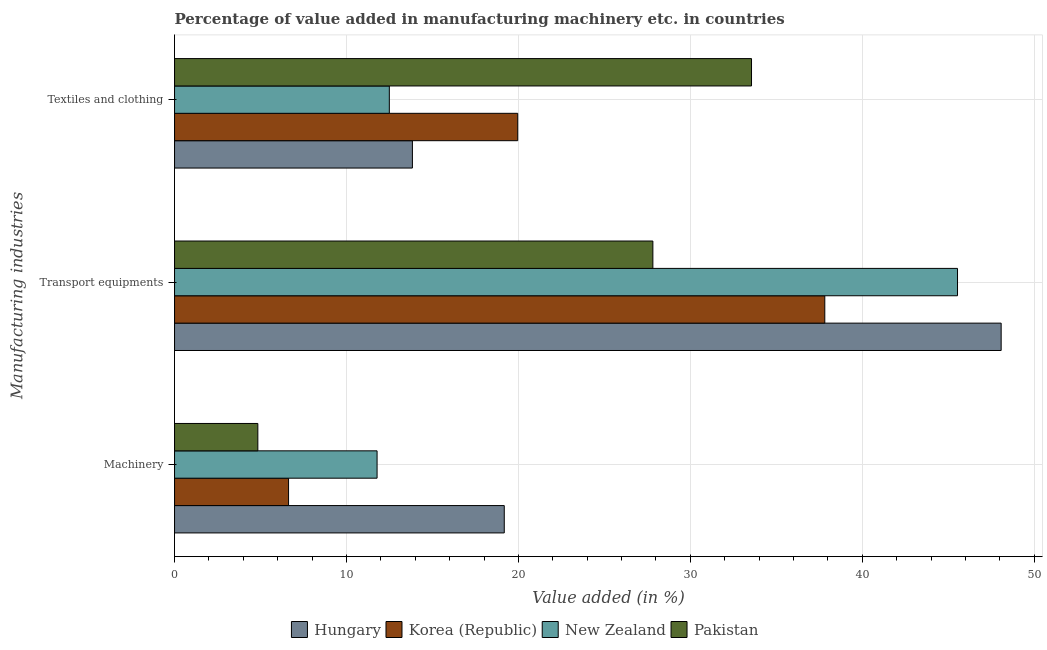Are the number of bars per tick equal to the number of legend labels?
Provide a short and direct response. Yes. Are the number of bars on each tick of the Y-axis equal?
Provide a succinct answer. Yes. What is the label of the 1st group of bars from the top?
Provide a succinct answer. Textiles and clothing. What is the value added in manufacturing textile and clothing in Hungary?
Provide a succinct answer. 13.83. Across all countries, what is the maximum value added in manufacturing machinery?
Your answer should be very brief. 19.18. Across all countries, what is the minimum value added in manufacturing textile and clothing?
Provide a succinct answer. 12.49. In which country was the value added in manufacturing machinery maximum?
Keep it short and to the point. Hungary. In which country was the value added in manufacturing textile and clothing minimum?
Provide a succinct answer. New Zealand. What is the total value added in manufacturing machinery in the graph?
Keep it short and to the point. 42.43. What is the difference between the value added in manufacturing transport equipments in Pakistan and that in Korea (Republic)?
Offer a terse response. -10. What is the difference between the value added in manufacturing textile and clothing in New Zealand and the value added in manufacturing transport equipments in Hungary?
Your response must be concise. -35.59. What is the average value added in manufacturing machinery per country?
Keep it short and to the point. 10.61. What is the difference between the value added in manufacturing textile and clothing and value added in manufacturing transport equipments in New Zealand?
Offer a very short reply. -33.05. In how many countries, is the value added in manufacturing transport equipments greater than 44 %?
Your answer should be very brief. 2. What is the ratio of the value added in manufacturing machinery in Hungary to that in Pakistan?
Your answer should be compact. 3.96. What is the difference between the highest and the second highest value added in manufacturing textile and clothing?
Offer a very short reply. 13.6. What is the difference between the highest and the lowest value added in manufacturing machinery?
Your answer should be very brief. 14.33. In how many countries, is the value added in manufacturing transport equipments greater than the average value added in manufacturing transport equipments taken over all countries?
Your answer should be very brief. 2. Is the sum of the value added in manufacturing transport equipments in New Zealand and Pakistan greater than the maximum value added in manufacturing textile and clothing across all countries?
Provide a succinct answer. Yes. What does the 3rd bar from the bottom in Transport equipments represents?
Ensure brevity in your answer.  New Zealand. Is it the case that in every country, the sum of the value added in manufacturing machinery and value added in manufacturing transport equipments is greater than the value added in manufacturing textile and clothing?
Make the answer very short. No. Are the values on the major ticks of X-axis written in scientific E-notation?
Keep it short and to the point. No. Does the graph contain grids?
Give a very brief answer. Yes. What is the title of the graph?
Offer a very short reply. Percentage of value added in manufacturing machinery etc. in countries. Does "Heavily indebted poor countries" appear as one of the legend labels in the graph?
Ensure brevity in your answer.  No. What is the label or title of the X-axis?
Your answer should be very brief. Value added (in %). What is the label or title of the Y-axis?
Your answer should be compact. Manufacturing industries. What is the Value added (in %) in Hungary in Machinery?
Provide a succinct answer. 19.18. What is the Value added (in %) of Korea (Republic) in Machinery?
Your response must be concise. 6.63. What is the Value added (in %) of New Zealand in Machinery?
Keep it short and to the point. 11.78. What is the Value added (in %) in Pakistan in Machinery?
Ensure brevity in your answer.  4.84. What is the Value added (in %) of Hungary in Transport equipments?
Offer a terse response. 48.08. What is the Value added (in %) in Korea (Republic) in Transport equipments?
Make the answer very short. 37.82. What is the Value added (in %) of New Zealand in Transport equipments?
Offer a very short reply. 45.54. What is the Value added (in %) in Pakistan in Transport equipments?
Make the answer very short. 27.82. What is the Value added (in %) of Hungary in Textiles and clothing?
Your answer should be very brief. 13.83. What is the Value added (in %) of Korea (Republic) in Textiles and clothing?
Offer a very short reply. 19.96. What is the Value added (in %) in New Zealand in Textiles and clothing?
Your response must be concise. 12.49. What is the Value added (in %) of Pakistan in Textiles and clothing?
Ensure brevity in your answer.  33.56. Across all Manufacturing industries, what is the maximum Value added (in %) in Hungary?
Keep it short and to the point. 48.08. Across all Manufacturing industries, what is the maximum Value added (in %) of Korea (Republic)?
Offer a terse response. 37.82. Across all Manufacturing industries, what is the maximum Value added (in %) of New Zealand?
Keep it short and to the point. 45.54. Across all Manufacturing industries, what is the maximum Value added (in %) in Pakistan?
Ensure brevity in your answer.  33.56. Across all Manufacturing industries, what is the minimum Value added (in %) in Hungary?
Your response must be concise. 13.83. Across all Manufacturing industries, what is the minimum Value added (in %) in Korea (Republic)?
Make the answer very short. 6.63. Across all Manufacturing industries, what is the minimum Value added (in %) in New Zealand?
Make the answer very short. 11.78. Across all Manufacturing industries, what is the minimum Value added (in %) of Pakistan?
Provide a short and direct response. 4.84. What is the total Value added (in %) in Hungary in the graph?
Give a very brief answer. 81.09. What is the total Value added (in %) of Korea (Republic) in the graph?
Give a very brief answer. 64.41. What is the total Value added (in %) in New Zealand in the graph?
Ensure brevity in your answer.  69.81. What is the total Value added (in %) in Pakistan in the graph?
Offer a very short reply. 66.22. What is the difference between the Value added (in %) in Hungary in Machinery and that in Transport equipments?
Make the answer very short. -28.9. What is the difference between the Value added (in %) in Korea (Republic) in Machinery and that in Transport equipments?
Provide a short and direct response. -31.19. What is the difference between the Value added (in %) in New Zealand in Machinery and that in Transport equipments?
Ensure brevity in your answer.  -33.76. What is the difference between the Value added (in %) of Pakistan in Machinery and that in Transport equipments?
Your response must be concise. -22.98. What is the difference between the Value added (in %) in Hungary in Machinery and that in Textiles and clothing?
Your response must be concise. 5.34. What is the difference between the Value added (in %) in Korea (Republic) in Machinery and that in Textiles and clothing?
Offer a terse response. -13.33. What is the difference between the Value added (in %) in New Zealand in Machinery and that in Textiles and clothing?
Your answer should be very brief. -0.71. What is the difference between the Value added (in %) of Pakistan in Machinery and that in Textiles and clothing?
Your answer should be compact. -28.71. What is the difference between the Value added (in %) in Hungary in Transport equipments and that in Textiles and clothing?
Your answer should be compact. 34.24. What is the difference between the Value added (in %) of Korea (Republic) in Transport equipments and that in Textiles and clothing?
Ensure brevity in your answer.  17.86. What is the difference between the Value added (in %) in New Zealand in Transport equipments and that in Textiles and clothing?
Provide a short and direct response. 33.05. What is the difference between the Value added (in %) of Pakistan in Transport equipments and that in Textiles and clothing?
Your answer should be very brief. -5.74. What is the difference between the Value added (in %) in Hungary in Machinery and the Value added (in %) in Korea (Republic) in Transport equipments?
Your answer should be very brief. -18.64. What is the difference between the Value added (in %) in Hungary in Machinery and the Value added (in %) in New Zealand in Transport equipments?
Offer a very short reply. -26.36. What is the difference between the Value added (in %) of Hungary in Machinery and the Value added (in %) of Pakistan in Transport equipments?
Your response must be concise. -8.64. What is the difference between the Value added (in %) in Korea (Republic) in Machinery and the Value added (in %) in New Zealand in Transport equipments?
Keep it short and to the point. -38.91. What is the difference between the Value added (in %) of Korea (Republic) in Machinery and the Value added (in %) of Pakistan in Transport equipments?
Offer a very short reply. -21.19. What is the difference between the Value added (in %) in New Zealand in Machinery and the Value added (in %) in Pakistan in Transport equipments?
Offer a very short reply. -16.04. What is the difference between the Value added (in %) of Hungary in Machinery and the Value added (in %) of Korea (Republic) in Textiles and clothing?
Offer a very short reply. -0.78. What is the difference between the Value added (in %) of Hungary in Machinery and the Value added (in %) of New Zealand in Textiles and clothing?
Make the answer very short. 6.69. What is the difference between the Value added (in %) in Hungary in Machinery and the Value added (in %) in Pakistan in Textiles and clothing?
Provide a succinct answer. -14.38. What is the difference between the Value added (in %) of Korea (Republic) in Machinery and the Value added (in %) of New Zealand in Textiles and clothing?
Provide a short and direct response. -5.86. What is the difference between the Value added (in %) in Korea (Republic) in Machinery and the Value added (in %) in Pakistan in Textiles and clothing?
Offer a terse response. -26.93. What is the difference between the Value added (in %) in New Zealand in Machinery and the Value added (in %) in Pakistan in Textiles and clothing?
Offer a very short reply. -21.78. What is the difference between the Value added (in %) of Hungary in Transport equipments and the Value added (in %) of Korea (Republic) in Textiles and clothing?
Your answer should be compact. 28.12. What is the difference between the Value added (in %) in Hungary in Transport equipments and the Value added (in %) in New Zealand in Textiles and clothing?
Your answer should be very brief. 35.59. What is the difference between the Value added (in %) of Hungary in Transport equipments and the Value added (in %) of Pakistan in Textiles and clothing?
Ensure brevity in your answer.  14.52. What is the difference between the Value added (in %) in Korea (Republic) in Transport equipments and the Value added (in %) in New Zealand in Textiles and clothing?
Offer a very short reply. 25.33. What is the difference between the Value added (in %) of Korea (Republic) in Transport equipments and the Value added (in %) of Pakistan in Textiles and clothing?
Provide a succinct answer. 4.26. What is the difference between the Value added (in %) in New Zealand in Transport equipments and the Value added (in %) in Pakistan in Textiles and clothing?
Your response must be concise. 11.98. What is the average Value added (in %) of Hungary per Manufacturing industries?
Your answer should be compact. 27.03. What is the average Value added (in %) in Korea (Republic) per Manufacturing industries?
Make the answer very short. 21.47. What is the average Value added (in %) in New Zealand per Manufacturing industries?
Offer a very short reply. 23.27. What is the average Value added (in %) in Pakistan per Manufacturing industries?
Provide a succinct answer. 22.07. What is the difference between the Value added (in %) of Hungary and Value added (in %) of Korea (Republic) in Machinery?
Give a very brief answer. 12.55. What is the difference between the Value added (in %) in Hungary and Value added (in %) in New Zealand in Machinery?
Your response must be concise. 7.4. What is the difference between the Value added (in %) in Hungary and Value added (in %) in Pakistan in Machinery?
Your answer should be very brief. 14.33. What is the difference between the Value added (in %) in Korea (Republic) and Value added (in %) in New Zealand in Machinery?
Your answer should be very brief. -5.15. What is the difference between the Value added (in %) of Korea (Republic) and Value added (in %) of Pakistan in Machinery?
Provide a succinct answer. 1.79. What is the difference between the Value added (in %) in New Zealand and Value added (in %) in Pakistan in Machinery?
Your answer should be very brief. 6.94. What is the difference between the Value added (in %) of Hungary and Value added (in %) of Korea (Republic) in Transport equipments?
Make the answer very short. 10.26. What is the difference between the Value added (in %) of Hungary and Value added (in %) of New Zealand in Transport equipments?
Your answer should be very brief. 2.54. What is the difference between the Value added (in %) of Hungary and Value added (in %) of Pakistan in Transport equipments?
Provide a succinct answer. 20.26. What is the difference between the Value added (in %) in Korea (Republic) and Value added (in %) in New Zealand in Transport equipments?
Ensure brevity in your answer.  -7.72. What is the difference between the Value added (in %) of Korea (Republic) and Value added (in %) of Pakistan in Transport equipments?
Give a very brief answer. 10. What is the difference between the Value added (in %) of New Zealand and Value added (in %) of Pakistan in Transport equipments?
Provide a succinct answer. 17.72. What is the difference between the Value added (in %) in Hungary and Value added (in %) in Korea (Republic) in Textiles and clothing?
Your response must be concise. -6.13. What is the difference between the Value added (in %) of Hungary and Value added (in %) of New Zealand in Textiles and clothing?
Make the answer very short. 1.34. What is the difference between the Value added (in %) in Hungary and Value added (in %) in Pakistan in Textiles and clothing?
Provide a short and direct response. -19.72. What is the difference between the Value added (in %) in Korea (Republic) and Value added (in %) in New Zealand in Textiles and clothing?
Provide a short and direct response. 7.47. What is the difference between the Value added (in %) of Korea (Republic) and Value added (in %) of Pakistan in Textiles and clothing?
Offer a terse response. -13.6. What is the difference between the Value added (in %) in New Zealand and Value added (in %) in Pakistan in Textiles and clothing?
Give a very brief answer. -21.07. What is the ratio of the Value added (in %) in Hungary in Machinery to that in Transport equipments?
Ensure brevity in your answer.  0.4. What is the ratio of the Value added (in %) of Korea (Republic) in Machinery to that in Transport equipments?
Your answer should be very brief. 0.18. What is the ratio of the Value added (in %) of New Zealand in Machinery to that in Transport equipments?
Your response must be concise. 0.26. What is the ratio of the Value added (in %) in Pakistan in Machinery to that in Transport equipments?
Give a very brief answer. 0.17. What is the ratio of the Value added (in %) of Hungary in Machinery to that in Textiles and clothing?
Offer a terse response. 1.39. What is the ratio of the Value added (in %) in Korea (Republic) in Machinery to that in Textiles and clothing?
Ensure brevity in your answer.  0.33. What is the ratio of the Value added (in %) in New Zealand in Machinery to that in Textiles and clothing?
Your answer should be compact. 0.94. What is the ratio of the Value added (in %) in Pakistan in Machinery to that in Textiles and clothing?
Keep it short and to the point. 0.14. What is the ratio of the Value added (in %) in Hungary in Transport equipments to that in Textiles and clothing?
Provide a succinct answer. 3.48. What is the ratio of the Value added (in %) in Korea (Republic) in Transport equipments to that in Textiles and clothing?
Keep it short and to the point. 1.89. What is the ratio of the Value added (in %) in New Zealand in Transport equipments to that in Textiles and clothing?
Offer a terse response. 3.65. What is the ratio of the Value added (in %) of Pakistan in Transport equipments to that in Textiles and clothing?
Provide a succinct answer. 0.83. What is the difference between the highest and the second highest Value added (in %) in Hungary?
Your response must be concise. 28.9. What is the difference between the highest and the second highest Value added (in %) of Korea (Republic)?
Provide a short and direct response. 17.86. What is the difference between the highest and the second highest Value added (in %) of New Zealand?
Offer a very short reply. 33.05. What is the difference between the highest and the second highest Value added (in %) of Pakistan?
Provide a short and direct response. 5.74. What is the difference between the highest and the lowest Value added (in %) of Hungary?
Make the answer very short. 34.24. What is the difference between the highest and the lowest Value added (in %) of Korea (Republic)?
Your answer should be very brief. 31.19. What is the difference between the highest and the lowest Value added (in %) of New Zealand?
Ensure brevity in your answer.  33.76. What is the difference between the highest and the lowest Value added (in %) of Pakistan?
Provide a short and direct response. 28.71. 